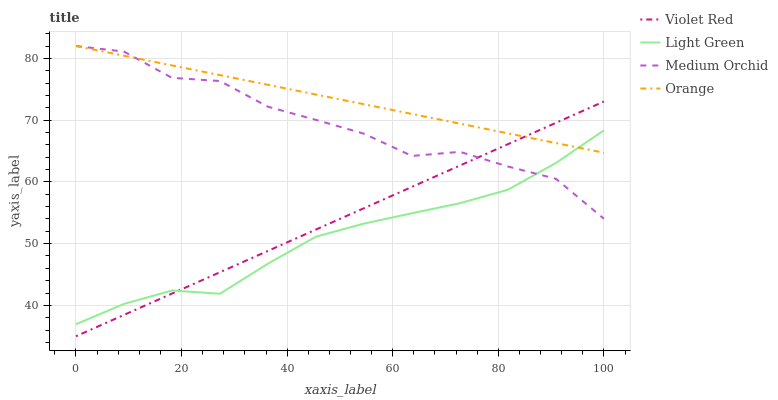Does Light Green have the minimum area under the curve?
Answer yes or no. Yes. Does Orange have the maximum area under the curve?
Answer yes or no. Yes. Does Violet Red have the minimum area under the curve?
Answer yes or no. No. Does Violet Red have the maximum area under the curve?
Answer yes or no. No. Is Orange the smoothest?
Answer yes or no. Yes. Is Medium Orchid the roughest?
Answer yes or no. Yes. Is Violet Red the smoothest?
Answer yes or no. No. Is Violet Red the roughest?
Answer yes or no. No. Does Violet Red have the lowest value?
Answer yes or no. Yes. Does Medium Orchid have the lowest value?
Answer yes or no. No. Does Medium Orchid have the highest value?
Answer yes or no. Yes. Does Violet Red have the highest value?
Answer yes or no. No. Does Medium Orchid intersect Light Green?
Answer yes or no. Yes. Is Medium Orchid less than Light Green?
Answer yes or no. No. Is Medium Orchid greater than Light Green?
Answer yes or no. No. 